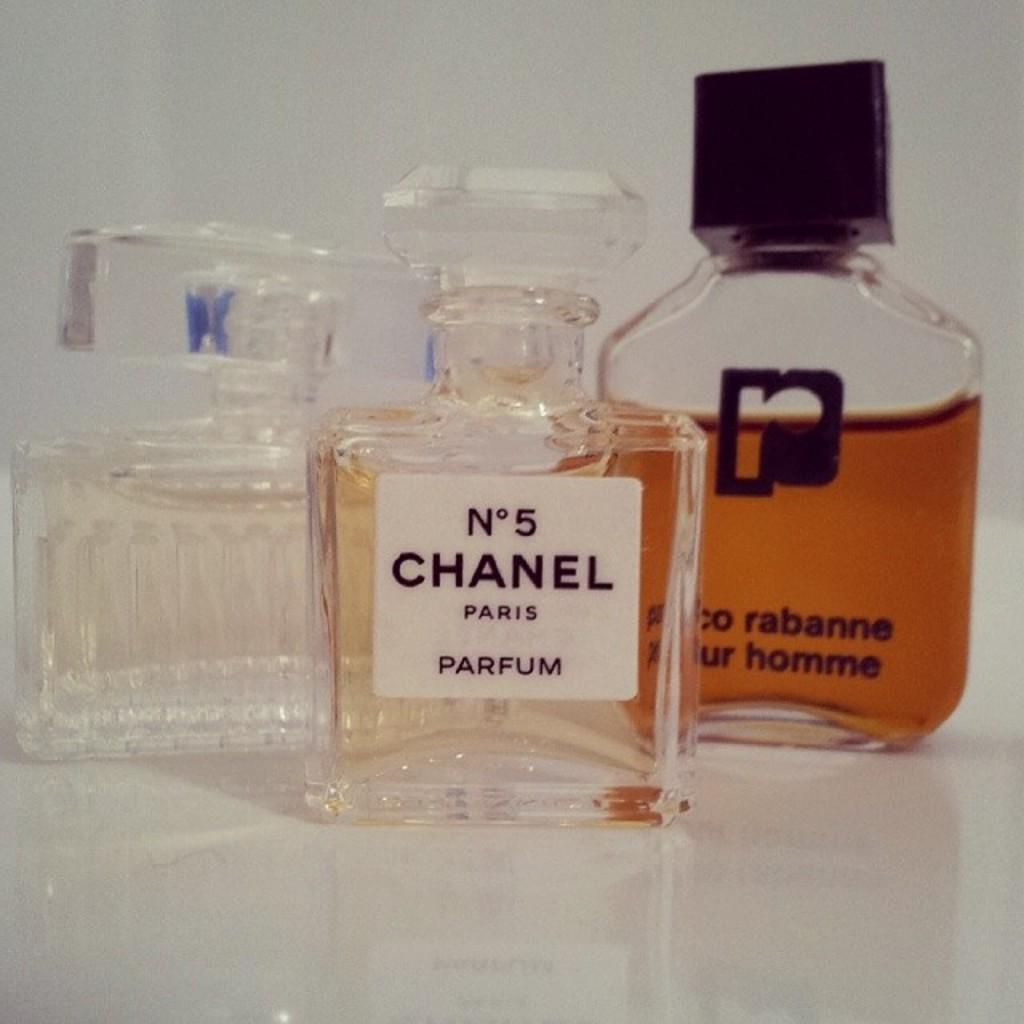<image>
Describe the image concisely. A bottle of Chanel No. 5 is on a table with two other perfume bottles. 